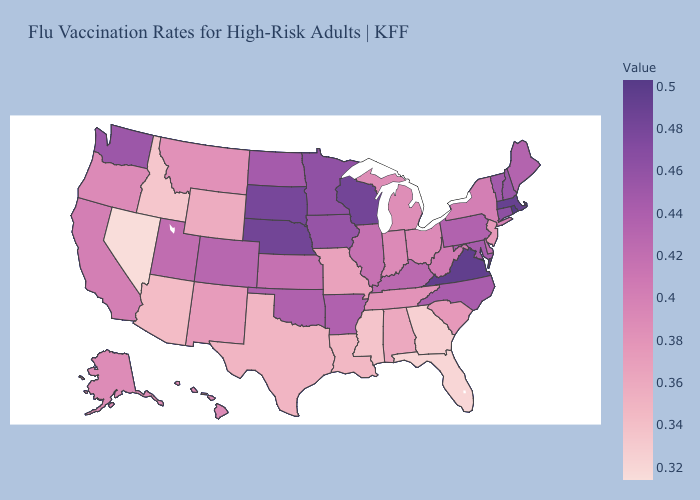Which states have the lowest value in the Northeast?
Be succinct. New Jersey. Does North Dakota have the lowest value in the MidWest?
Answer briefly. No. Which states have the lowest value in the South?
Short answer required. Florida. Does South Carolina have a lower value than Florida?
Be succinct. No. Which states have the lowest value in the USA?
Give a very brief answer. Nevada. Among the states that border Tennessee , which have the highest value?
Keep it brief. Virginia. Does New Mexico have a higher value than Mississippi?
Short answer required. Yes. Which states have the lowest value in the West?
Be succinct. Nevada. Does Louisiana have the lowest value in the USA?
Be succinct. No. Does the map have missing data?
Concise answer only. No. 